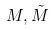<formula> <loc_0><loc_0><loc_500><loc_500>M , \tilde { M }</formula> 